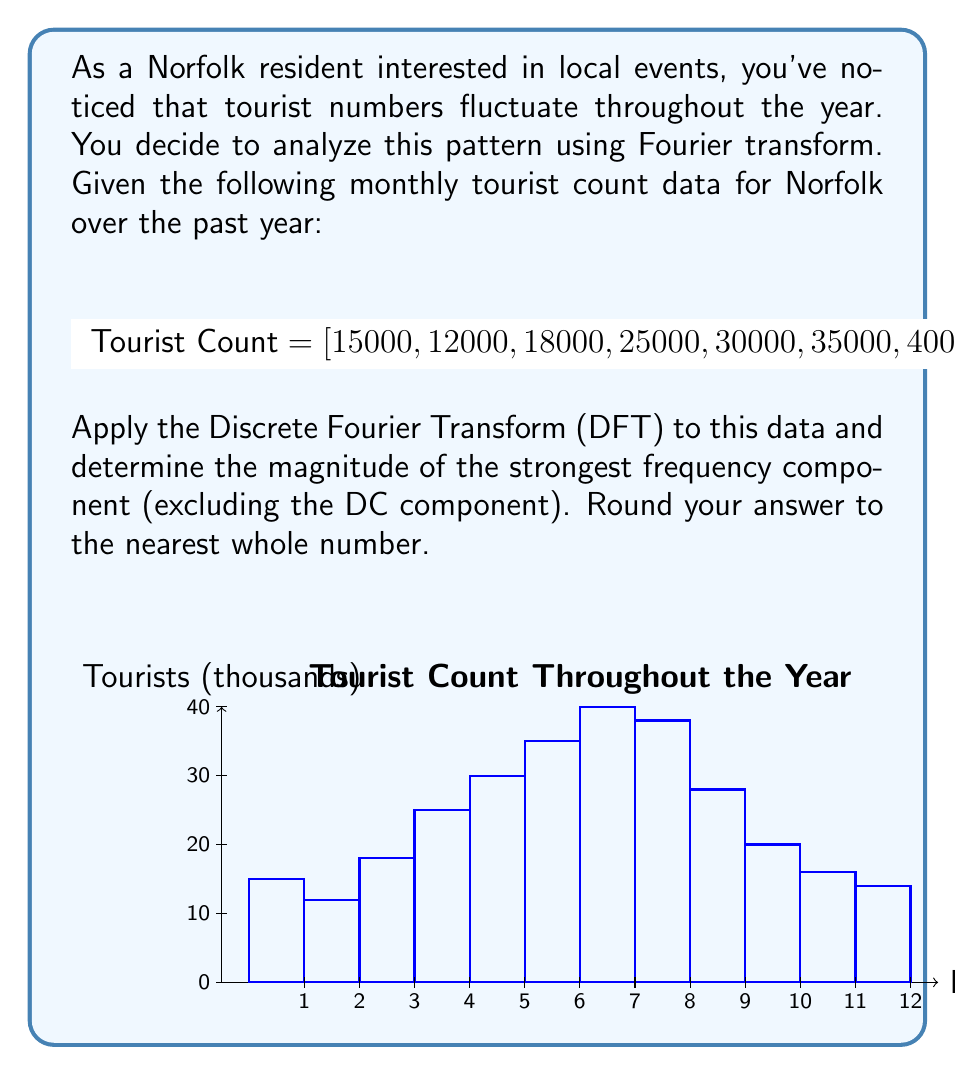Give your solution to this math problem. Let's approach this step-by-step:

1) The Discrete Fourier Transform (DFT) of a sequence $x[n]$ of length N is given by:

   $$X[k] = \sum_{n=0}^{N-1} x[n] e^{-j2\pi kn/N}$$

   where $k = 0, 1, ..., N-1$

2) In this case, $N = 12$ (12 months of data)

3) We need to calculate $X[k]$ for $k = 0, 1, ..., 11$

4) The magnitude of each frequency component is given by $|X[k]| = \sqrt{\text{Re}(X[k])^2 + \text{Im}(X[k])^2}$

5) Let's calculate a few values:

   For $k = 0$ (DC component):
   $$X[0] = \sum_{n=0}^{11} x[n] = 291000$$

   For $k = 1$:
   $$X[1] = 15000 + 12000e^{-j\pi/6} + 18000e^{-j\pi/3} + ... + 14000e^{-j11\pi/6}$$

6) Calculating all values (this would typically be done with a computer):

   $|X[0]| = 291000$
   $|X[1]| = |X[11]| \approx 13782$
   $|X[2]| = |X[10]| \approx 10954$
   $|X[3]| = |X[9]| \approx 3638$
   $|X[4]| = |X[8]| \approx 2182$
   $|X[5]| = |X[7]| \approx 1591$
   $|X[6]| \approx 1000$

7) The strongest frequency component (excluding DC) is $|X[1]| = |X[11]| \approx 13782$

8) Rounding to the nearest whole number: 13782
Answer: 13782 